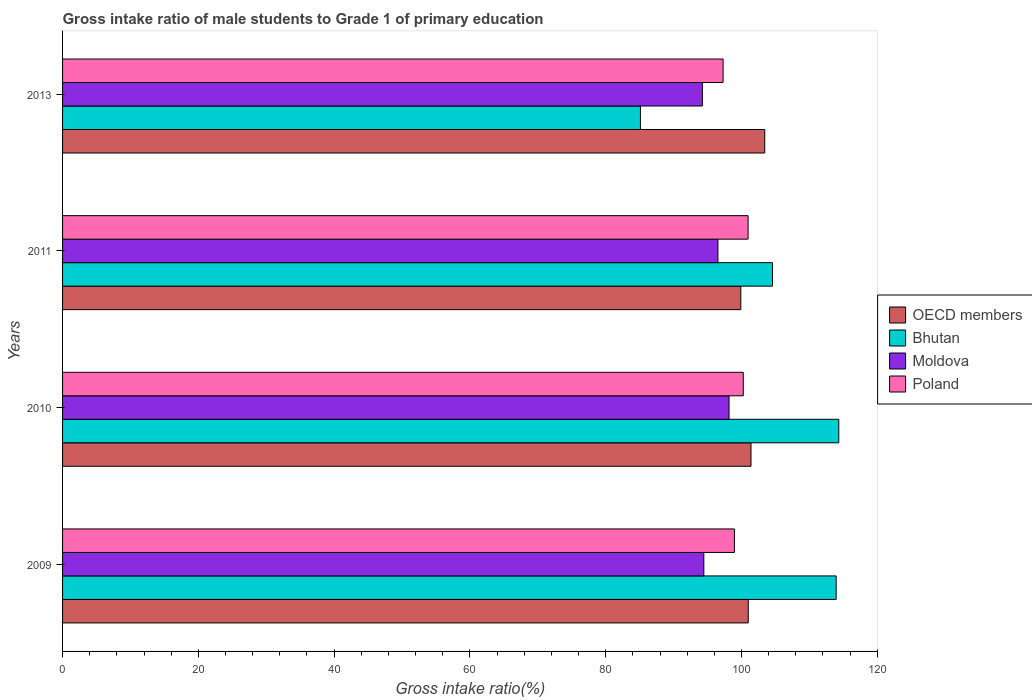Are the number of bars on each tick of the Y-axis equal?
Your answer should be very brief. Yes. How many bars are there on the 1st tick from the bottom?
Your response must be concise. 4. What is the gross intake ratio in OECD members in 2013?
Make the answer very short. 103.43. Across all years, what is the maximum gross intake ratio in Bhutan?
Provide a succinct answer. 114.33. Across all years, what is the minimum gross intake ratio in Moldova?
Provide a short and direct response. 94.24. In which year was the gross intake ratio in Moldova maximum?
Ensure brevity in your answer.  2010. What is the total gross intake ratio in Moldova in the graph?
Ensure brevity in your answer.  383.4. What is the difference between the gross intake ratio in OECD members in 2009 and that in 2013?
Ensure brevity in your answer.  -2.43. What is the difference between the gross intake ratio in OECD members in 2010 and the gross intake ratio in Bhutan in 2013?
Make the answer very short. 16.29. What is the average gross intake ratio in Bhutan per year?
Make the answer very short. 104.49. In the year 2011, what is the difference between the gross intake ratio in Poland and gross intake ratio in Moldova?
Your response must be concise. 4.44. What is the ratio of the gross intake ratio in OECD members in 2010 to that in 2011?
Provide a short and direct response. 1.02. Is the difference between the gross intake ratio in Poland in 2010 and 2013 greater than the difference between the gross intake ratio in Moldova in 2010 and 2013?
Provide a succinct answer. No. What is the difference between the highest and the second highest gross intake ratio in Poland?
Your answer should be compact. 0.71. What is the difference between the highest and the lowest gross intake ratio in OECD members?
Keep it short and to the point. 3.52. Is the sum of the gross intake ratio in Poland in 2010 and 2011 greater than the maximum gross intake ratio in Moldova across all years?
Make the answer very short. Yes. What does the 2nd bar from the top in 2011 represents?
Provide a succinct answer. Moldova. What does the 4th bar from the bottom in 2010 represents?
Keep it short and to the point. Poland. Is it the case that in every year, the sum of the gross intake ratio in OECD members and gross intake ratio in Moldova is greater than the gross intake ratio in Poland?
Your response must be concise. Yes. Are all the bars in the graph horizontal?
Your response must be concise. Yes. What is the difference between two consecutive major ticks on the X-axis?
Provide a succinct answer. 20. Does the graph contain any zero values?
Your answer should be very brief. No. Does the graph contain grids?
Provide a succinct answer. No. How many legend labels are there?
Give a very brief answer. 4. How are the legend labels stacked?
Keep it short and to the point. Vertical. What is the title of the graph?
Give a very brief answer. Gross intake ratio of male students to Grade 1 of primary education. What is the label or title of the X-axis?
Your answer should be compact. Gross intake ratio(%). What is the Gross intake ratio(%) of OECD members in 2009?
Provide a succinct answer. 101. What is the Gross intake ratio(%) of Bhutan in 2009?
Ensure brevity in your answer.  113.95. What is the Gross intake ratio(%) in Moldova in 2009?
Your answer should be compact. 94.46. What is the Gross intake ratio(%) of Poland in 2009?
Provide a succinct answer. 98.96. What is the Gross intake ratio(%) in OECD members in 2010?
Your answer should be very brief. 101.4. What is the Gross intake ratio(%) in Bhutan in 2010?
Provide a short and direct response. 114.33. What is the Gross intake ratio(%) in Moldova in 2010?
Make the answer very short. 98.17. What is the Gross intake ratio(%) of Poland in 2010?
Ensure brevity in your answer.  100.27. What is the Gross intake ratio(%) in OECD members in 2011?
Provide a succinct answer. 99.91. What is the Gross intake ratio(%) in Bhutan in 2011?
Offer a terse response. 104.57. What is the Gross intake ratio(%) in Moldova in 2011?
Give a very brief answer. 96.53. What is the Gross intake ratio(%) of Poland in 2011?
Your answer should be very brief. 100.98. What is the Gross intake ratio(%) of OECD members in 2013?
Offer a terse response. 103.43. What is the Gross intake ratio(%) in Bhutan in 2013?
Provide a succinct answer. 85.12. What is the Gross intake ratio(%) in Moldova in 2013?
Your answer should be very brief. 94.24. What is the Gross intake ratio(%) of Poland in 2013?
Provide a short and direct response. 97.3. Across all years, what is the maximum Gross intake ratio(%) in OECD members?
Your answer should be very brief. 103.43. Across all years, what is the maximum Gross intake ratio(%) of Bhutan?
Make the answer very short. 114.33. Across all years, what is the maximum Gross intake ratio(%) of Moldova?
Make the answer very short. 98.17. Across all years, what is the maximum Gross intake ratio(%) of Poland?
Your answer should be very brief. 100.98. Across all years, what is the minimum Gross intake ratio(%) of OECD members?
Give a very brief answer. 99.91. Across all years, what is the minimum Gross intake ratio(%) of Bhutan?
Your answer should be compact. 85.12. Across all years, what is the minimum Gross intake ratio(%) in Moldova?
Your answer should be very brief. 94.24. Across all years, what is the minimum Gross intake ratio(%) in Poland?
Keep it short and to the point. 97.3. What is the total Gross intake ratio(%) of OECD members in the graph?
Your answer should be compact. 405.74. What is the total Gross intake ratio(%) of Bhutan in the graph?
Your response must be concise. 417.97. What is the total Gross intake ratio(%) in Moldova in the graph?
Make the answer very short. 383.4. What is the total Gross intake ratio(%) of Poland in the graph?
Make the answer very short. 397.51. What is the difference between the Gross intake ratio(%) of OECD members in 2009 and that in 2010?
Your answer should be very brief. -0.41. What is the difference between the Gross intake ratio(%) of Bhutan in 2009 and that in 2010?
Your response must be concise. -0.39. What is the difference between the Gross intake ratio(%) in Moldova in 2009 and that in 2010?
Provide a succinct answer. -3.71. What is the difference between the Gross intake ratio(%) in Poland in 2009 and that in 2010?
Your answer should be compact. -1.3. What is the difference between the Gross intake ratio(%) of OECD members in 2009 and that in 2011?
Provide a succinct answer. 1.09. What is the difference between the Gross intake ratio(%) of Bhutan in 2009 and that in 2011?
Provide a succinct answer. 9.38. What is the difference between the Gross intake ratio(%) of Moldova in 2009 and that in 2011?
Offer a very short reply. -2.08. What is the difference between the Gross intake ratio(%) in Poland in 2009 and that in 2011?
Keep it short and to the point. -2.01. What is the difference between the Gross intake ratio(%) of OECD members in 2009 and that in 2013?
Your answer should be very brief. -2.43. What is the difference between the Gross intake ratio(%) in Bhutan in 2009 and that in 2013?
Your answer should be compact. 28.83. What is the difference between the Gross intake ratio(%) of Moldova in 2009 and that in 2013?
Offer a very short reply. 0.21. What is the difference between the Gross intake ratio(%) of Poland in 2009 and that in 2013?
Make the answer very short. 1.67. What is the difference between the Gross intake ratio(%) of OECD members in 2010 and that in 2011?
Give a very brief answer. 1.5. What is the difference between the Gross intake ratio(%) of Bhutan in 2010 and that in 2011?
Your answer should be very brief. 9.77. What is the difference between the Gross intake ratio(%) of Moldova in 2010 and that in 2011?
Make the answer very short. 1.64. What is the difference between the Gross intake ratio(%) in Poland in 2010 and that in 2011?
Your answer should be very brief. -0.71. What is the difference between the Gross intake ratio(%) of OECD members in 2010 and that in 2013?
Provide a short and direct response. -2.03. What is the difference between the Gross intake ratio(%) of Bhutan in 2010 and that in 2013?
Ensure brevity in your answer.  29.21. What is the difference between the Gross intake ratio(%) in Moldova in 2010 and that in 2013?
Your answer should be very brief. 3.93. What is the difference between the Gross intake ratio(%) in Poland in 2010 and that in 2013?
Your answer should be compact. 2.97. What is the difference between the Gross intake ratio(%) in OECD members in 2011 and that in 2013?
Ensure brevity in your answer.  -3.52. What is the difference between the Gross intake ratio(%) in Bhutan in 2011 and that in 2013?
Offer a very short reply. 19.45. What is the difference between the Gross intake ratio(%) of Moldova in 2011 and that in 2013?
Give a very brief answer. 2.29. What is the difference between the Gross intake ratio(%) in Poland in 2011 and that in 2013?
Provide a succinct answer. 3.68. What is the difference between the Gross intake ratio(%) of OECD members in 2009 and the Gross intake ratio(%) of Bhutan in 2010?
Offer a very short reply. -13.34. What is the difference between the Gross intake ratio(%) of OECD members in 2009 and the Gross intake ratio(%) of Moldova in 2010?
Your answer should be very brief. 2.83. What is the difference between the Gross intake ratio(%) in OECD members in 2009 and the Gross intake ratio(%) in Poland in 2010?
Keep it short and to the point. 0.73. What is the difference between the Gross intake ratio(%) of Bhutan in 2009 and the Gross intake ratio(%) of Moldova in 2010?
Provide a succinct answer. 15.78. What is the difference between the Gross intake ratio(%) of Bhutan in 2009 and the Gross intake ratio(%) of Poland in 2010?
Provide a short and direct response. 13.68. What is the difference between the Gross intake ratio(%) in Moldova in 2009 and the Gross intake ratio(%) in Poland in 2010?
Ensure brevity in your answer.  -5.81. What is the difference between the Gross intake ratio(%) in OECD members in 2009 and the Gross intake ratio(%) in Bhutan in 2011?
Keep it short and to the point. -3.57. What is the difference between the Gross intake ratio(%) in OECD members in 2009 and the Gross intake ratio(%) in Moldova in 2011?
Your response must be concise. 4.47. What is the difference between the Gross intake ratio(%) of OECD members in 2009 and the Gross intake ratio(%) of Poland in 2011?
Your answer should be compact. 0.02. What is the difference between the Gross intake ratio(%) of Bhutan in 2009 and the Gross intake ratio(%) of Moldova in 2011?
Your answer should be very brief. 17.42. What is the difference between the Gross intake ratio(%) in Bhutan in 2009 and the Gross intake ratio(%) in Poland in 2011?
Make the answer very short. 12.97. What is the difference between the Gross intake ratio(%) in Moldova in 2009 and the Gross intake ratio(%) in Poland in 2011?
Offer a very short reply. -6.52. What is the difference between the Gross intake ratio(%) in OECD members in 2009 and the Gross intake ratio(%) in Bhutan in 2013?
Keep it short and to the point. 15.88. What is the difference between the Gross intake ratio(%) in OECD members in 2009 and the Gross intake ratio(%) in Moldova in 2013?
Your response must be concise. 6.76. What is the difference between the Gross intake ratio(%) of OECD members in 2009 and the Gross intake ratio(%) of Poland in 2013?
Make the answer very short. 3.7. What is the difference between the Gross intake ratio(%) in Bhutan in 2009 and the Gross intake ratio(%) in Moldova in 2013?
Your response must be concise. 19.71. What is the difference between the Gross intake ratio(%) in Bhutan in 2009 and the Gross intake ratio(%) in Poland in 2013?
Your answer should be very brief. 16.65. What is the difference between the Gross intake ratio(%) of Moldova in 2009 and the Gross intake ratio(%) of Poland in 2013?
Keep it short and to the point. -2.84. What is the difference between the Gross intake ratio(%) of OECD members in 2010 and the Gross intake ratio(%) of Bhutan in 2011?
Offer a very short reply. -3.16. What is the difference between the Gross intake ratio(%) of OECD members in 2010 and the Gross intake ratio(%) of Moldova in 2011?
Ensure brevity in your answer.  4.87. What is the difference between the Gross intake ratio(%) in OECD members in 2010 and the Gross intake ratio(%) in Poland in 2011?
Offer a very short reply. 0.43. What is the difference between the Gross intake ratio(%) in Bhutan in 2010 and the Gross intake ratio(%) in Moldova in 2011?
Keep it short and to the point. 17.8. What is the difference between the Gross intake ratio(%) of Bhutan in 2010 and the Gross intake ratio(%) of Poland in 2011?
Offer a terse response. 13.36. What is the difference between the Gross intake ratio(%) in Moldova in 2010 and the Gross intake ratio(%) in Poland in 2011?
Offer a terse response. -2.81. What is the difference between the Gross intake ratio(%) of OECD members in 2010 and the Gross intake ratio(%) of Bhutan in 2013?
Keep it short and to the point. 16.29. What is the difference between the Gross intake ratio(%) of OECD members in 2010 and the Gross intake ratio(%) of Moldova in 2013?
Your answer should be very brief. 7.16. What is the difference between the Gross intake ratio(%) in OECD members in 2010 and the Gross intake ratio(%) in Poland in 2013?
Your answer should be compact. 4.11. What is the difference between the Gross intake ratio(%) in Bhutan in 2010 and the Gross intake ratio(%) in Moldova in 2013?
Keep it short and to the point. 20.09. What is the difference between the Gross intake ratio(%) in Bhutan in 2010 and the Gross intake ratio(%) in Poland in 2013?
Give a very brief answer. 17.04. What is the difference between the Gross intake ratio(%) of Moldova in 2010 and the Gross intake ratio(%) of Poland in 2013?
Offer a very short reply. 0.87. What is the difference between the Gross intake ratio(%) of OECD members in 2011 and the Gross intake ratio(%) of Bhutan in 2013?
Provide a succinct answer. 14.79. What is the difference between the Gross intake ratio(%) in OECD members in 2011 and the Gross intake ratio(%) in Moldova in 2013?
Ensure brevity in your answer.  5.66. What is the difference between the Gross intake ratio(%) of OECD members in 2011 and the Gross intake ratio(%) of Poland in 2013?
Ensure brevity in your answer.  2.61. What is the difference between the Gross intake ratio(%) of Bhutan in 2011 and the Gross intake ratio(%) of Moldova in 2013?
Your answer should be very brief. 10.32. What is the difference between the Gross intake ratio(%) of Bhutan in 2011 and the Gross intake ratio(%) of Poland in 2013?
Offer a terse response. 7.27. What is the difference between the Gross intake ratio(%) of Moldova in 2011 and the Gross intake ratio(%) of Poland in 2013?
Provide a succinct answer. -0.76. What is the average Gross intake ratio(%) of OECD members per year?
Provide a short and direct response. 101.43. What is the average Gross intake ratio(%) of Bhutan per year?
Keep it short and to the point. 104.49. What is the average Gross intake ratio(%) of Moldova per year?
Your response must be concise. 95.85. What is the average Gross intake ratio(%) in Poland per year?
Provide a short and direct response. 99.38. In the year 2009, what is the difference between the Gross intake ratio(%) in OECD members and Gross intake ratio(%) in Bhutan?
Your response must be concise. -12.95. In the year 2009, what is the difference between the Gross intake ratio(%) of OECD members and Gross intake ratio(%) of Moldova?
Offer a terse response. 6.54. In the year 2009, what is the difference between the Gross intake ratio(%) in OECD members and Gross intake ratio(%) in Poland?
Your answer should be very brief. 2.03. In the year 2009, what is the difference between the Gross intake ratio(%) in Bhutan and Gross intake ratio(%) in Moldova?
Your answer should be very brief. 19.49. In the year 2009, what is the difference between the Gross intake ratio(%) of Bhutan and Gross intake ratio(%) of Poland?
Offer a very short reply. 14.98. In the year 2009, what is the difference between the Gross intake ratio(%) of Moldova and Gross intake ratio(%) of Poland?
Make the answer very short. -4.51. In the year 2010, what is the difference between the Gross intake ratio(%) of OECD members and Gross intake ratio(%) of Bhutan?
Provide a succinct answer. -12.93. In the year 2010, what is the difference between the Gross intake ratio(%) of OECD members and Gross intake ratio(%) of Moldova?
Provide a short and direct response. 3.24. In the year 2010, what is the difference between the Gross intake ratio(%) in OECD members and Gross intake ratio(%) in Poland?
Offer a very short reply. 1.14. In the year 2010, what is the difference between the Gross intake ratio(%) in Bhutan and Gross intake ratio(%) in Moldova?
Keep it short and to the point. 16.17. In the year 2010, what is the difference between the Gross intake ratio(%) of Bhutan and Gross intake ratio(%) of Poland?
Make the answer very short. 14.07. In the year 2010, what is the difference between the Gross intake ratio(%) of Moldova and Gross intake ratio(%) of Poland?
Make the answer very short. -2.1. In the year 2011, what is the difference between the Gross intake ratio(%) in OECD members and Gross intake ratio(%) in Bhutan?
Give a very brief answer. -4.66. In the year 2011, what is the difference between the Gross intake ratio(%) in OECD members and Gross intake ratio(%) in Moldova?
Your answer should be compact. 3.37. In the year 2011, what is the difference between the Gross intake ratio(%) in OECD members and Gross intake ratio(%) in Poland?
Offer a terse response. -1.07. In the year 2011, what is the difference between the Gross intake ratio(%) in Bhutan and Gross intake ratio(%) in Moldova?
Your answer should be very brief. 8.03. In the year 2011, what is the difference between the Gross intake ratio(%) of Bhutan and Gross intake ratio(%) of Poland?
Keep it short and to the point. 3.59. In the year 2011, what is the difference between the Gross intake ratio(%) of Moldova and Gross intake ratio(%) of Poland?
Keep it short and to the point. -4.44. In the year 2013, what is the difference between the Gross intake ratio(%) in OECD members and Gross intake ratio(%) in Bhutan?
Your answer should be very brief. 18.31. In the year 2013, what is the difference between the Gross intake ratio(%) of OECD members and Gross intake ratio(%) of Moldova?
Provide a succinct answer. 9.19. In the year 2013, what is the difference between the Gross intake ratio(%) of OECD members and Gross intake ratio(%) of Poland?
Your response must be concise. 6.13. In the year 2013, what is the difference between the Gross intake ratio(%) of Bhutan and Gross intake ratio(%) of Moldova?
Give a very brief answer. -9.12. In the year 2013, what is the difference between the Gross intake ratio(%) in Bhutan and Gross intake ratio(%) in Poland?
Keep it short and to the point. -12.18. In the year 2013, what is the difference between the Gross intake ratio(%) in Moldova and Gross intake ratio(%) in Poland?
Offer a very short reply. -3.05. What is the ratio of the Gross intake ratio(%) in OECD members in 2009 to that in 2010?
Give a very brief answer. 1. What is the ratio of the Gross intake ratio(%) of Moldova in 2009 to that in 2010?
Provide a succinct answer. 0.96. What is the ratio of the Gross intake ratio(%) of Poland in 2009 to that in 2010?
Keep it short and to the point. 0.99. What is the ratio of the Gross intake ratio(%) of OECD members in 2009 to that in 2011?
Offer a very short reply. 1.01. What is the ratio of the Gross intake ratio(%) of Bhutan in 2009 to that in 2011?
Make the answer very short. 1.09. What is the ratio of the Gross intake ratio(%) in Moldova in 2009 to that in 2011?
Your answer should be compact. 0.98. What is the ratio of the Gross intake ratio(%) in Poland in 2009 to that in 2011?
Offer a very short reply. 0.98. What is the ratio of the Gross intake ratio(%) of OECD members in 2009 to that in 2013?
Your response must be concise. 0.98. What is the ratio of the Gross intake ratio(%) of Bhutan in 2009 to that in 2013?
Provide a succinct answer. 1.34. What is the ratio of the Gross intake ratio(%) in Poland in 2009 to that in 2013?
Your response must be concise. 1.02. What is the ratio of the Gross intake ratio(%) of OECD members in 2010 to that in 2011?
Provide a succinct answer. 1.01. What is the ratio of the Gross intake ratio(%) in Bhutan in 2010 to that in 2011?
Offer a very short reply. 1.09. What is the ratio of the Gross intake ratio(%) of Moldova in 2010 to that in 2011?
Offer a terse response. 1.02. What is the ratio of the Gross intake ratio(%) in Poland in 2010 to that in 2011?
Offer a very short reply. 0.99. What is the ratio of the Gross intake ratio(%) of OECD members in 2010 to that in 2013?
Your answer should be compact. 0.98. What is the ratio of the Gross intake ratio(%) of Bhutan in 2010 to that in 2013?
Keep it short and to the point. 1.34. What is the ratio of the Gross intake ratio(%) of Moldova in 2010 to that in 2013?
Give a very brief answer. 1.04. What is the ratio of the Gross intake ratio(%) in Poland in 2010 to that in 2013?
Provide a short and direct response. 1.03. What is the ratio of the Gross intake ratio(%) in OECD members in 2011 to that in 2013?
Your response must be concise. 0.97. What is the ratio of the Gross intake ratio(%) in Bhutan in 2011 to that in 2013?
Keep it short and to the point. 1.23. What is the ratio of the Gross intake ratio(%) of Moldova in 2011 to that in 2013?
Your answer should be very brief. 1.02. What is the ratio of the Gross intake ratio(%) in Poland in 2011 to that in 2013?
Offer a very short reply. 1.04. What is the difference between the highest and the second highest Gross intake ratio(%) of OECD members?
Offer a very short reply. 2.03. What is the difference between the highest and the second highest Gross intake ratio(%) of Bhutan?
Your response must be concise. 0.39. What is the difference between the highest and the second highest Gross intake ratio(%) of Moldova?
Offer a very short reply. 1.64. What is the difference between the highest and the second highest Gross intake ratio(%) of Poland?
Keep it short and to the point. 0.71. What is the difference between the highest and the lowest Gross intake ratio(%) in OECD members?
Make the answer very short. 3.52. What is the difference between the highest and the lowest Gross intake ratio(%) of Bhutan?
Give a very brief answer. 29.21. What is the difference between the highest and the lowest Gross intake ratio(%) of Moldova?
Provide a short and direct response. 3.93. What is the difference between the highest and the lowest Gross intake ratio(%) of Poland?
Keep it short and to the point. 3.68. 